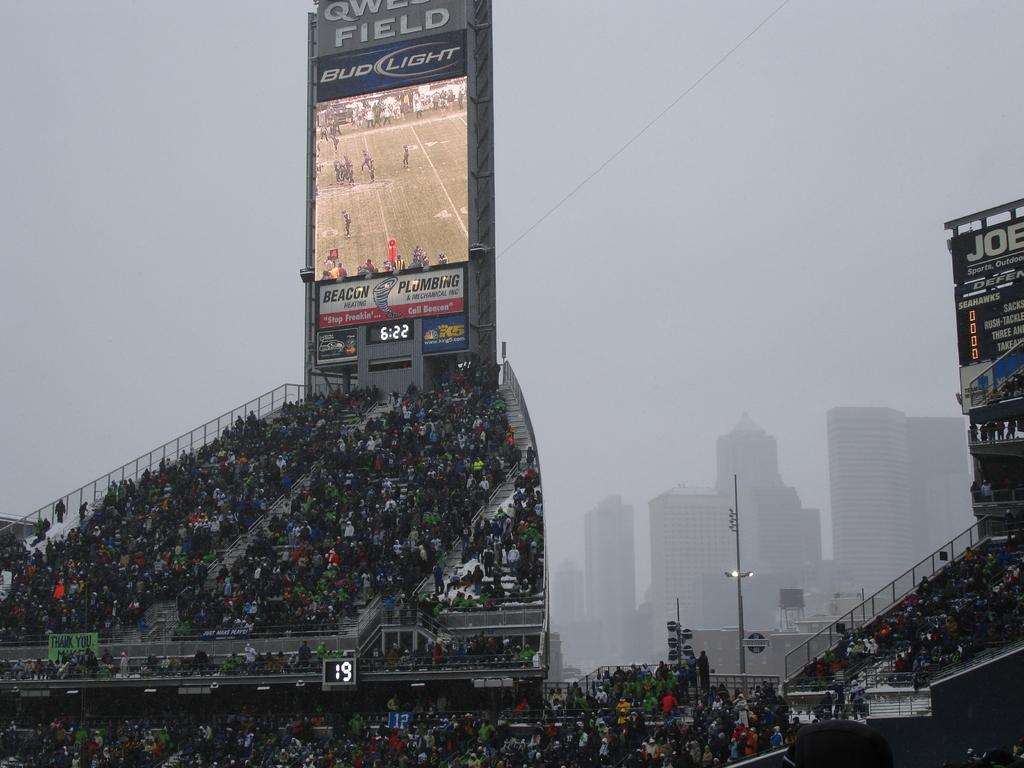Provide a one-sentence caption for the provided image. Bud light is a sponsor for one of the big screens at the ball field. 